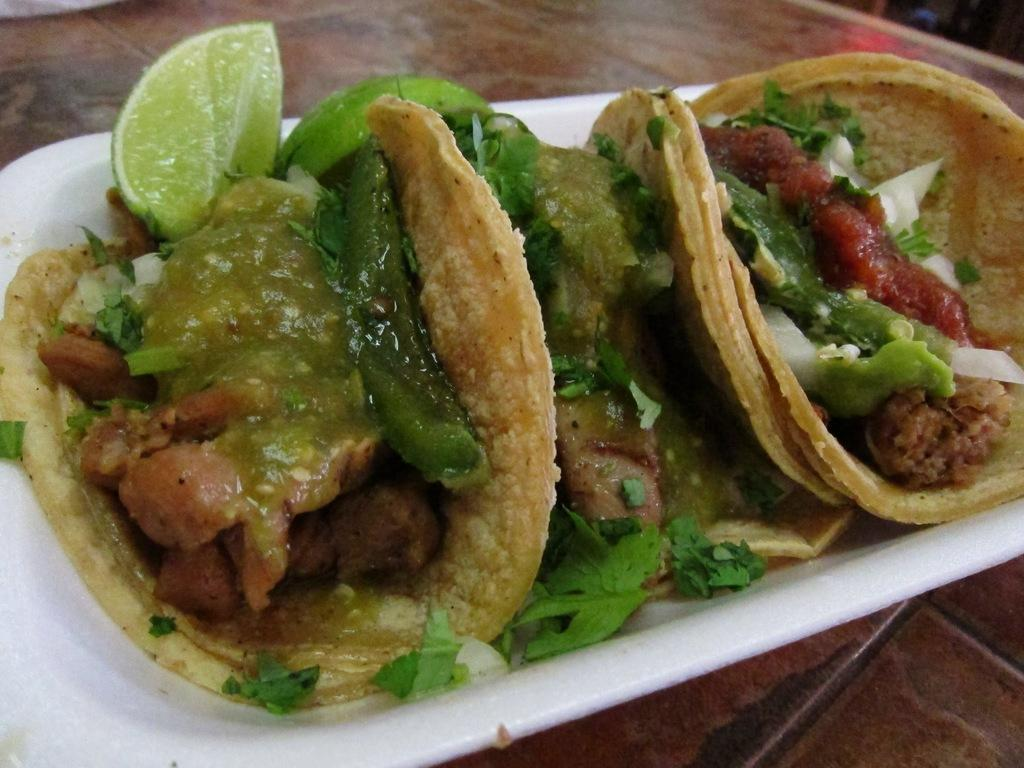What type of food is featured in the image? The image contains tacos. What are the main ingredients of the tacos? There is meat and veggies in the tacos. What is present on the plate alongside the tacos? Lemon pieces are present on the plate. Where is the plate located? The plate is on a table. How many children are visible in the image? There are no children present in the image; it features tacos, meat, veggies, lemon pieces, and a plate on a table. What type of fruit is being used as a topping for the tacos in the image? There is no fruit present as a topping for the tacos in the image; the only toppings mentioned are meat and veggies. 